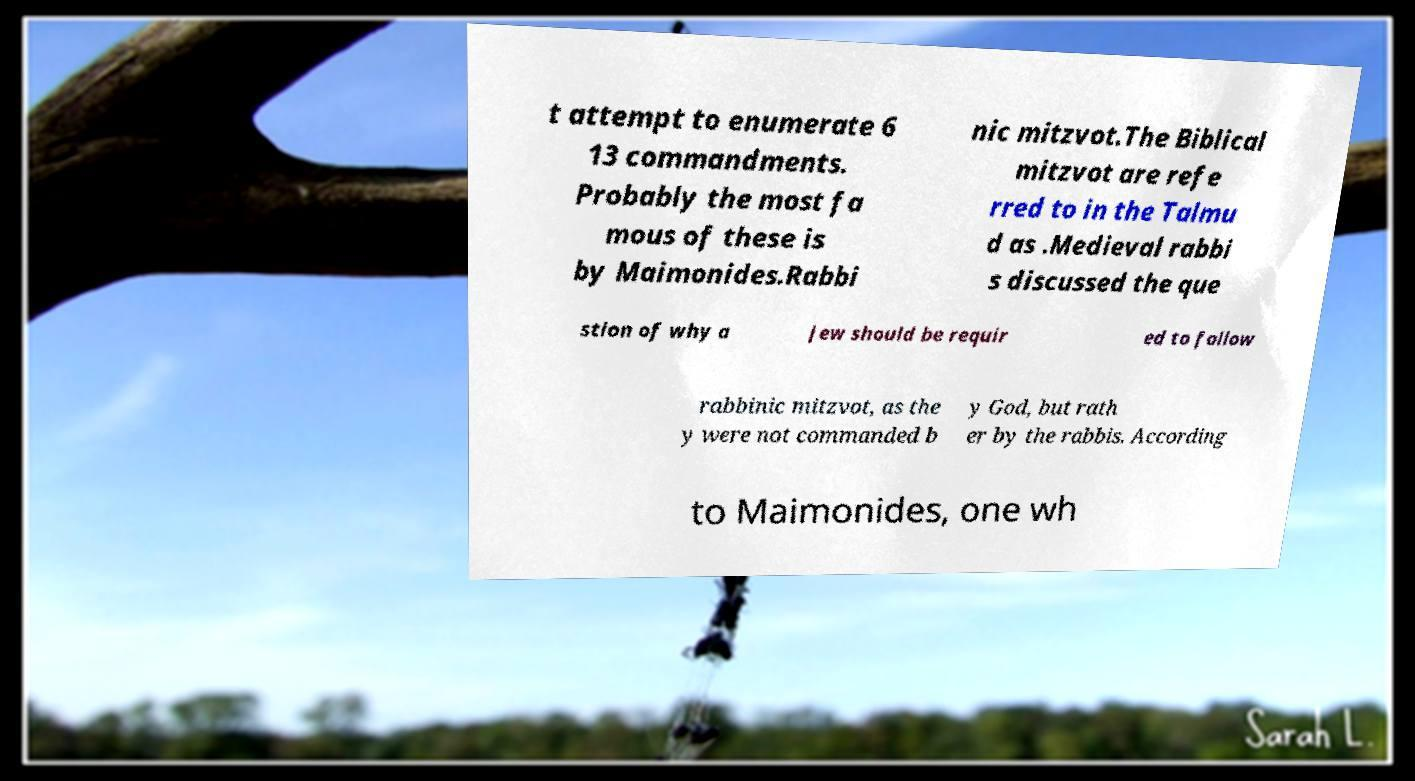Please identify and transcribe the text found in this image. t attempt to enumerate 6 13 commandments. Probably the most fa mous of these is by Maimonides.Rabbi nic mitzvot.The Biblical mitzvot are refe rred to in the Talmu d as .Medieval rabbi s discussed the que stion of why a Jew should be requir ed to follow rabbinic mitzvot, as the y were not commanded b y God, but rath er by the rabbis. According to Maimonides, one wh 